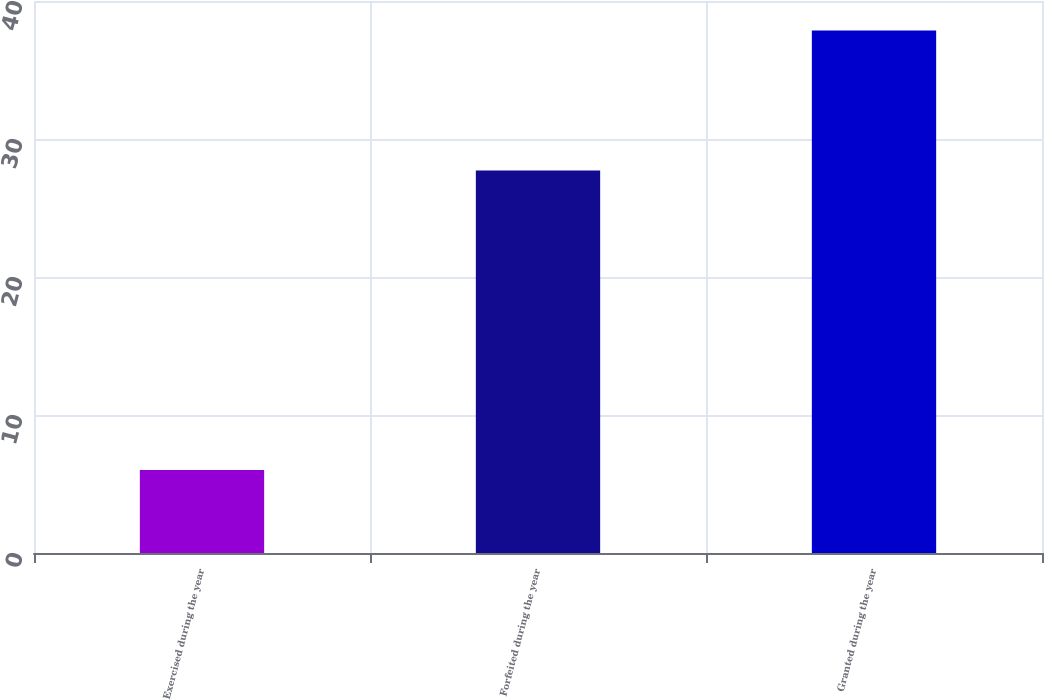Convert chart to OTSL. <chart><loc_0><loc_0><loc_500><loc_500><bar_chart><fcel>Exercised during the year<fcel>Forfeited during the year<fcel>Granted during the year<nl><fcel>6.01<fcel>27.71<fcel>37.86<nl></chart> 